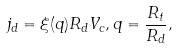Convert formula to latex. <formula><loc_0><loc_0><loc_500><loc_500>j _ { d } = \xi ( q ) R _ { d } V _ { c } , q = \frac { R _ { t } } { R _ { d } } ,</formula> 